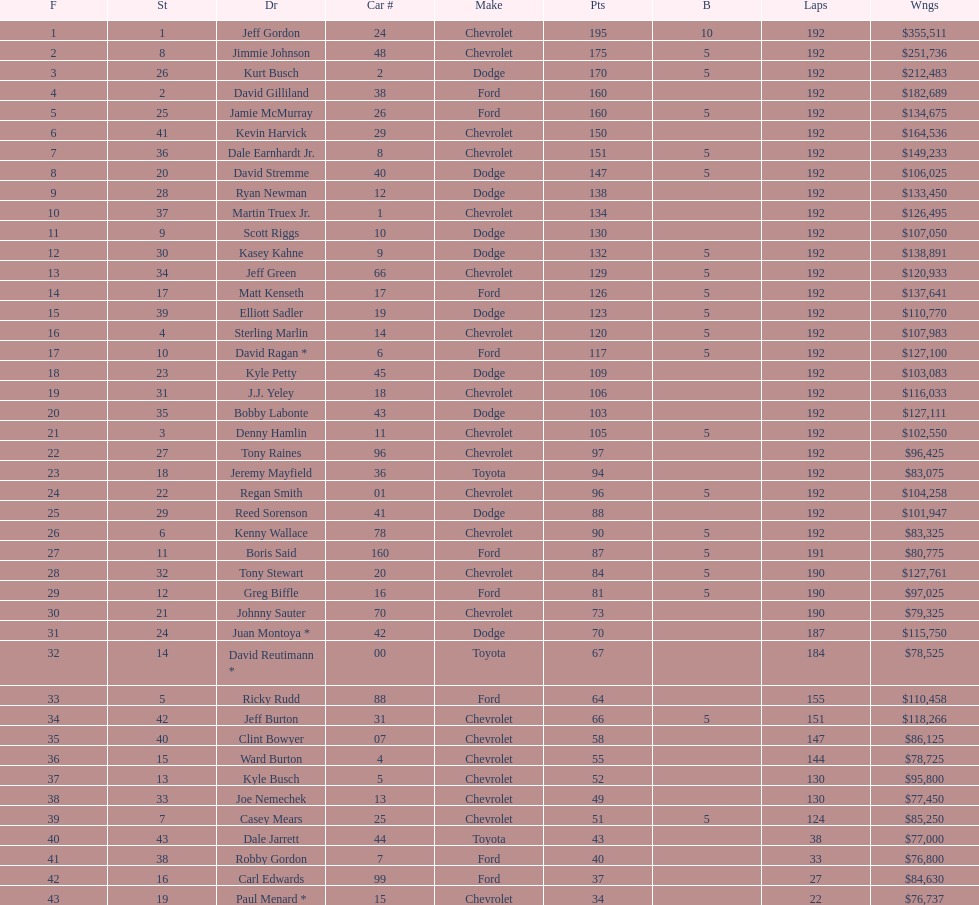What was the make of both jeff gordon's and jimmie johnson's race car? Chevrolet. 